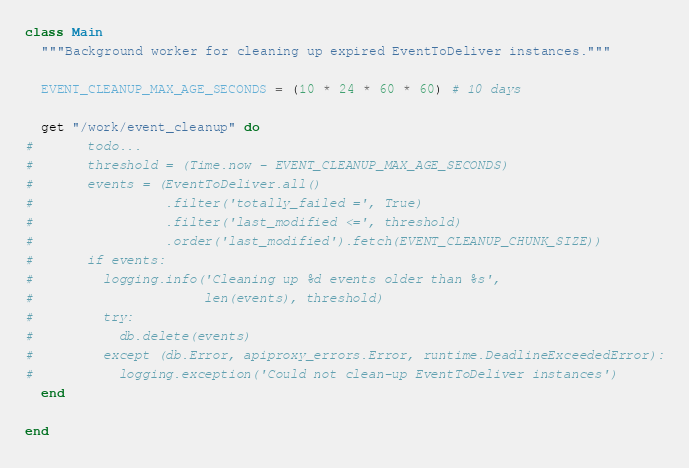<code> <loc_0><loc_0><loc_500><loc_500><_Ruby_>class Main
  """Background worker for cleaning up expired EventToDeliver instances."""

  EVENT_CLEANUP_MAX_AGE_SECONDS = (10 * 24 * 60 * 60) # 10 days

  get "/work/event_cleanup" do
#       todo...
#       threshold = (Time.now - EVENT_CLEANUP_MAX_AGE_SECONDS)
#       events = (EventToDeliver.all()
#                 .filter('totally_failed =', True)
#                 .filter('last_modified <=', threshold)
#                 .order('last_modified').fetch(EVENT_CLEANUP_CHUNK_SIZE))
#       if events:
#         logging.info('Cleaning up %d events older than %s',
#                      len(events), threshold)
#         try:
#           db.delete(events)
#         except (db.Error, apiproxy_errors.Error, runtime.DeadlineExceededError):
#           logging.exception('Could not clean-up EventToDeliver instances')
  end

end</code> 